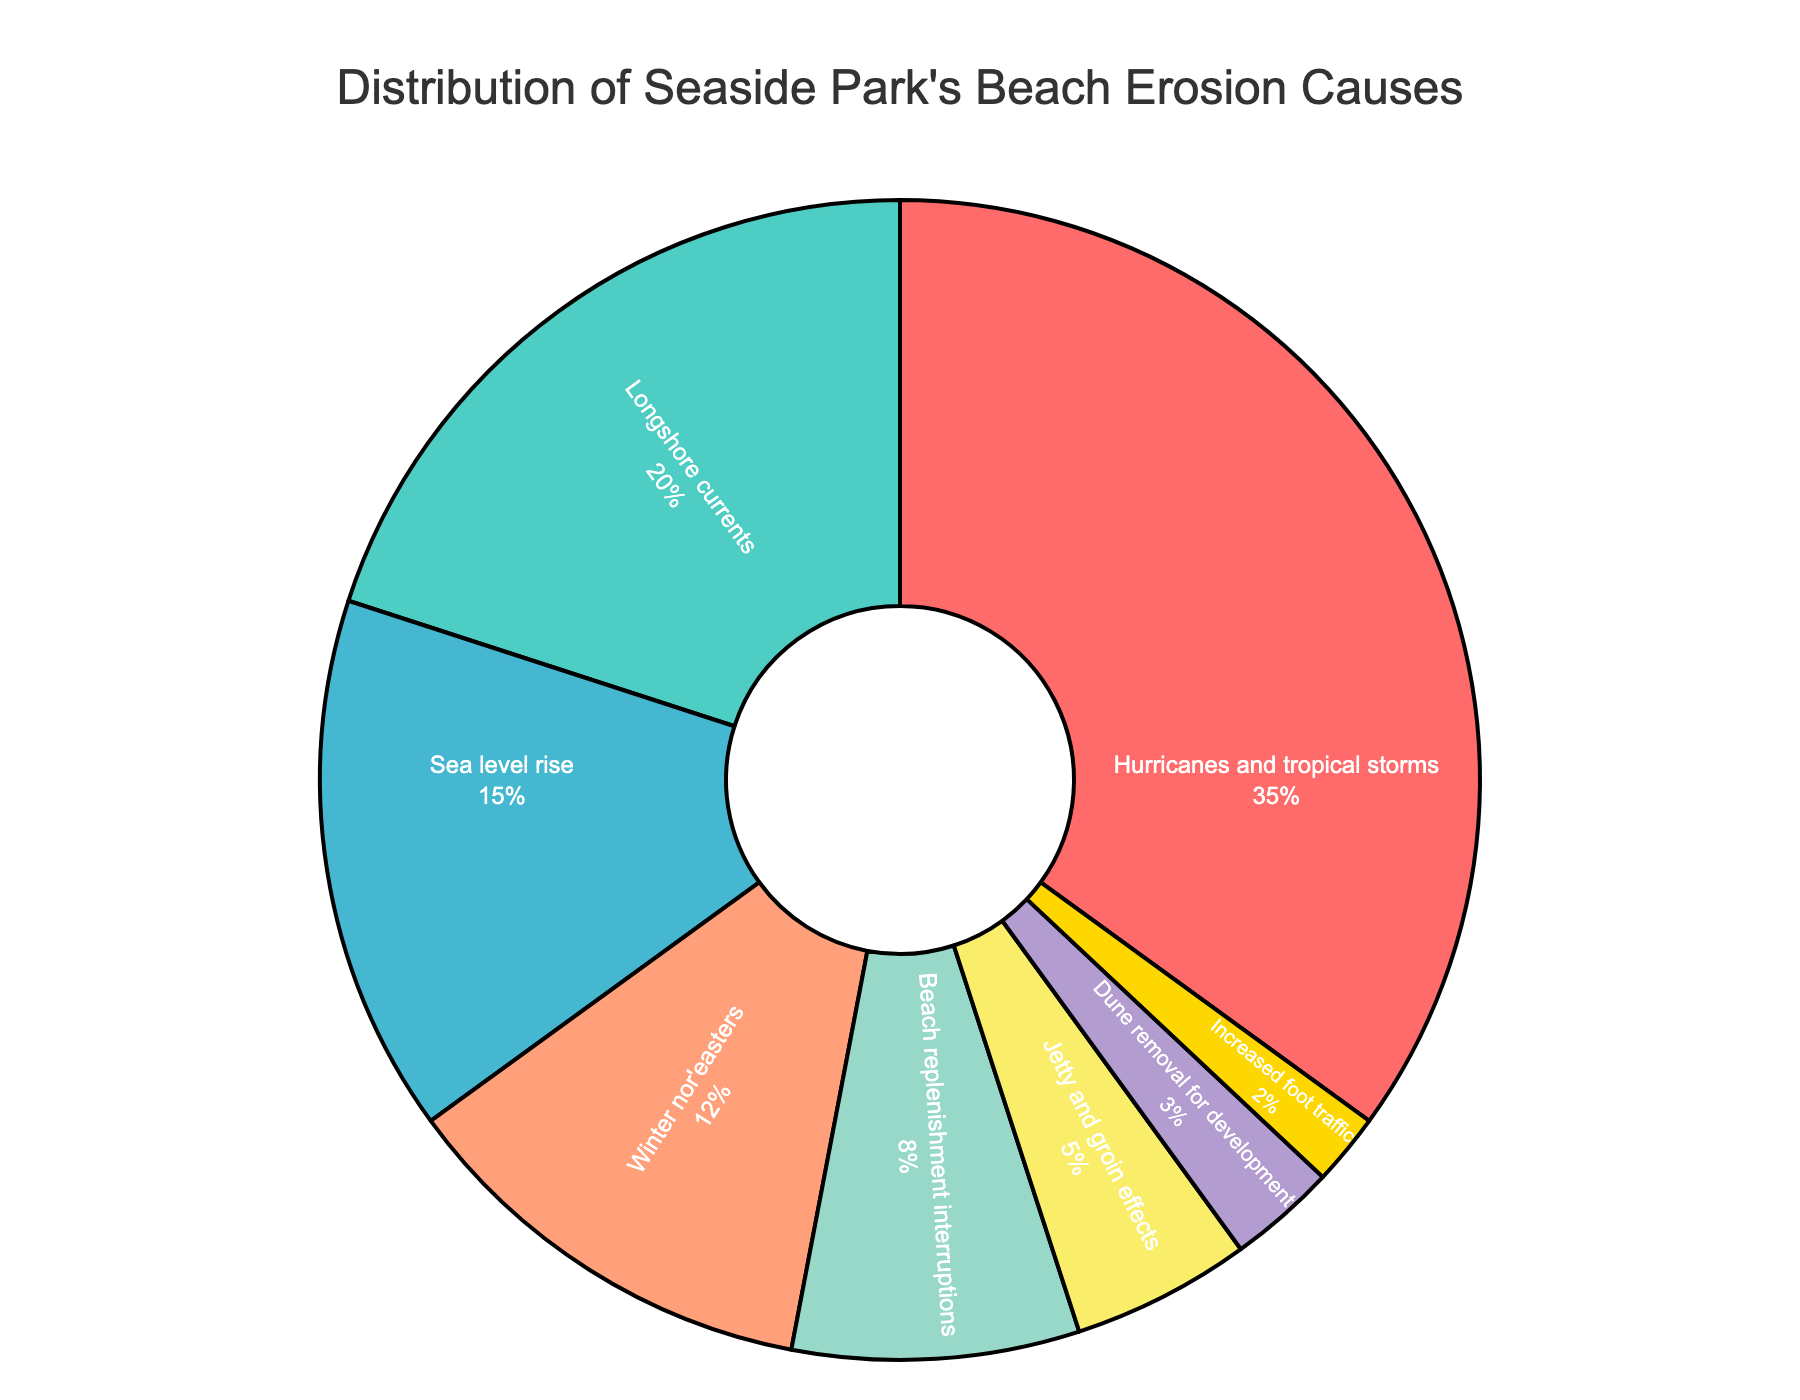What's the largest cause of beach erosion in Seaside Park? By looking at the pie chart, identify which cause has the largest section. The label "Hurricanes and tropical storms" has the largest section at 35%.
Answer: Hurricanes and tropical storms What percentage of beach erosion is due to human activities? Add the percentages for "Beach replenishment interruptions" (8%), "Jetty and groin effects" (5%), "Dune removal for development" (3%), and "Increased foot traffic" (2%). 8 + 5 + 3 + 2 = 18%
Answer: 18% Is sea level rise a more significant cause of beach erosion than winter nor'easters? Compare the percentage values on the pie chart. "Sea level rise" is 15%, and "Winter nor'easters" is 12%.
Answer: Yes Which cause has the smallest contribution to beach erosion? Identify the smallest section in the pie chart. The label "Increased foot traffic" has the smallest section at 2%.
Answer: Increased foot traffic How much greater is the contribution of longshore currents compared to jetty and groin effects? Subtract the percentage of "Jetty and groin effects" (5%) from "Longshore currents" (20%). 20 - 5 = 15%
Answer: 15% What is the combined percentage of beach erosion caused by natural processes (excluding storms)? Add the percentages for "Longshore currents" and "Sea level rise." 20 + 15 = 35%
Answer: 35% What percentage of beach erosion is attributed to storms (including hurricanes, tropical storms, and winter nor'easters)? Add the percentages for "Hurricanes and tropical storms" (35%) and "Winter nor'easters" (12%). 35 + 12 = 47%
Answer: 47% Is the visual representation of "Dune removal for development" or "Beach replenishment interruptions" larger? Compare the sizes of the sections for "Dune removal for development" and "Beach replenishment interruptions." "Beach replenishment interruptions" is 8%, while "Dune removal for development" is 3%.
Answer: Beach replenishment interruptions What percentage do the two most minor causes of beach erosion together contribute? Add the percentages for "Dune removal for development" (3%) and "Increased foot traffic" (2%). 3 + 2 = 5%
Answer: 5% By how much does the contribution of "Hurricanes and tropical storms" exceed that of "Sea level rise"? Subtract the percentage of "Sea level rise" (15%) from "Hurricanes and tropical storms" (35%). 35 - 15 = 20%
Answer: 20% 